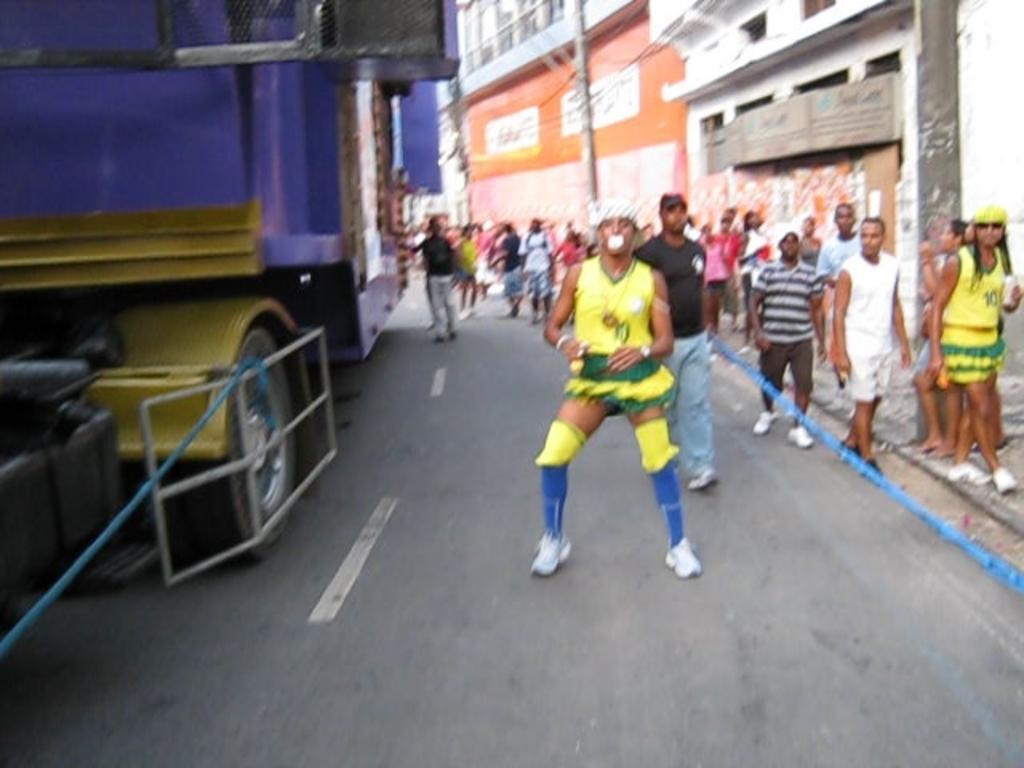What is the main feature of the image? There is a road in the image. What can be seen on the road? There is a vehicle on the road. How many people are present in the image? There are many people in the image. What is located on the right side of the image? There is a building on the right side of the image. What objects are present in the image that are not related to the road or people? There are tapes in the image. How many geese are walking on the top of the building in the image? There are no geese present in the image, and the image does not show the top of the building. 